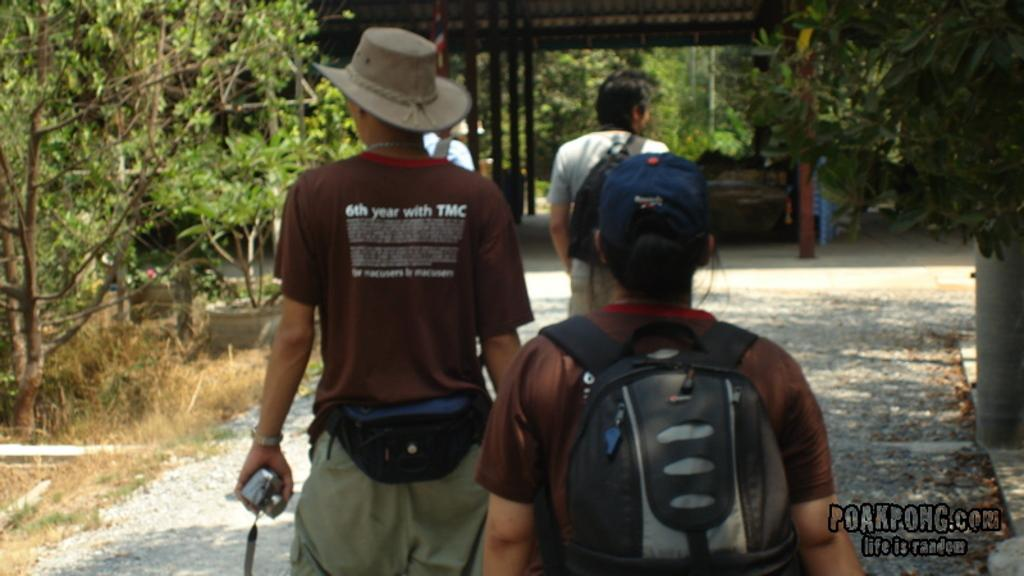<image>
Describe the image concisely. One of the men walking has 6th year with TMC written on his shirt 